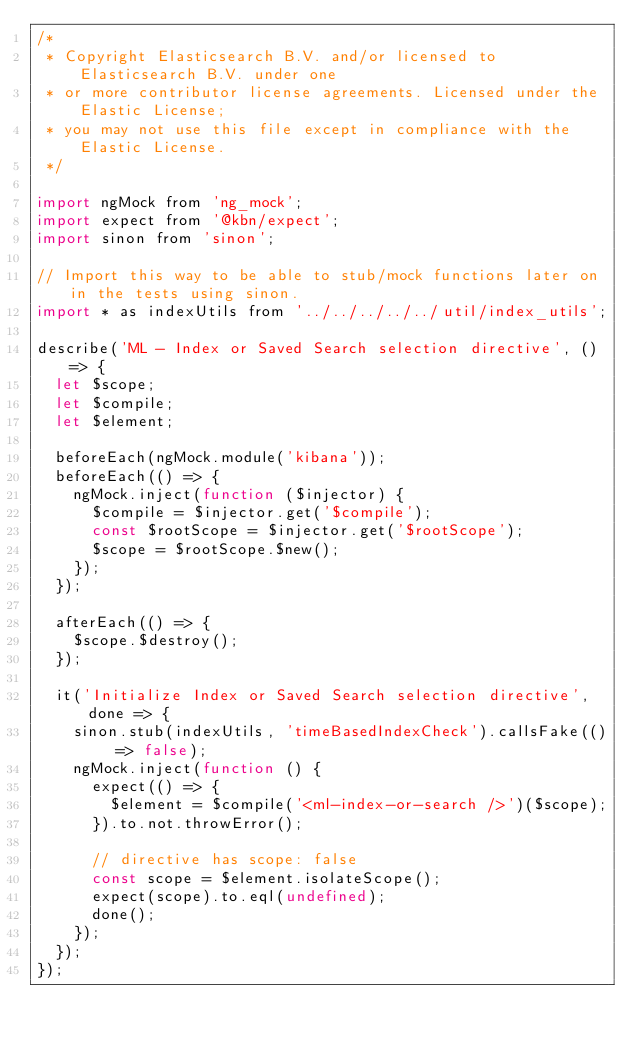<code> <loc_0><loc_0><loc_500><loc_500><_JavaScript_>/*
 * Copyright Elasticsearch B.V. and/or licensed to Elasticsearch B.V. under one
 * or more contributor license agreements. Licensed under the Elastic License;
 * you may not use this file except in compliance with the Elastic License.
 */

import ngMock from 'ng_mock';
import expect from '@kbn/expect';
import sinon from 'sinon';

// Import this way to be able to stub/mock functions later on in the tests using sinon.
import * as indexUtils from '../../../../../util/index_utils';

describe('ML - Index or Saved Search selection directive', () => {
  let $scope;
  let $compile;
  let $element;

  beforeEach(ngMock.module('kibana'));
  beforeEach(() => {
    ngMock.inject(function ($injector) {
      $compile = $injector.get('$compile');
      const $rootScope = $injector.get('$rootScope');
      $scope = $rootScope.$new();
    });
  });

  afterEach(() => {
    $scope.$destroy();
  });

  it('Initialize Index or Saved Search selection directive', done => {
    sinon.stub(indexUtils, 'timeBasedIndexCheck').callsFake(() => false);
    ngMock.inject(function () {
      expect(() => {
        $element = $compile('<ml-index-or-search />')($scope);
      }).to.not.throwError();

      // directive has scope: false
      const scope = $element.isolateScope();
      expect(scope).to.eql(undefined);
      done();
    });
  });
});
</code> 